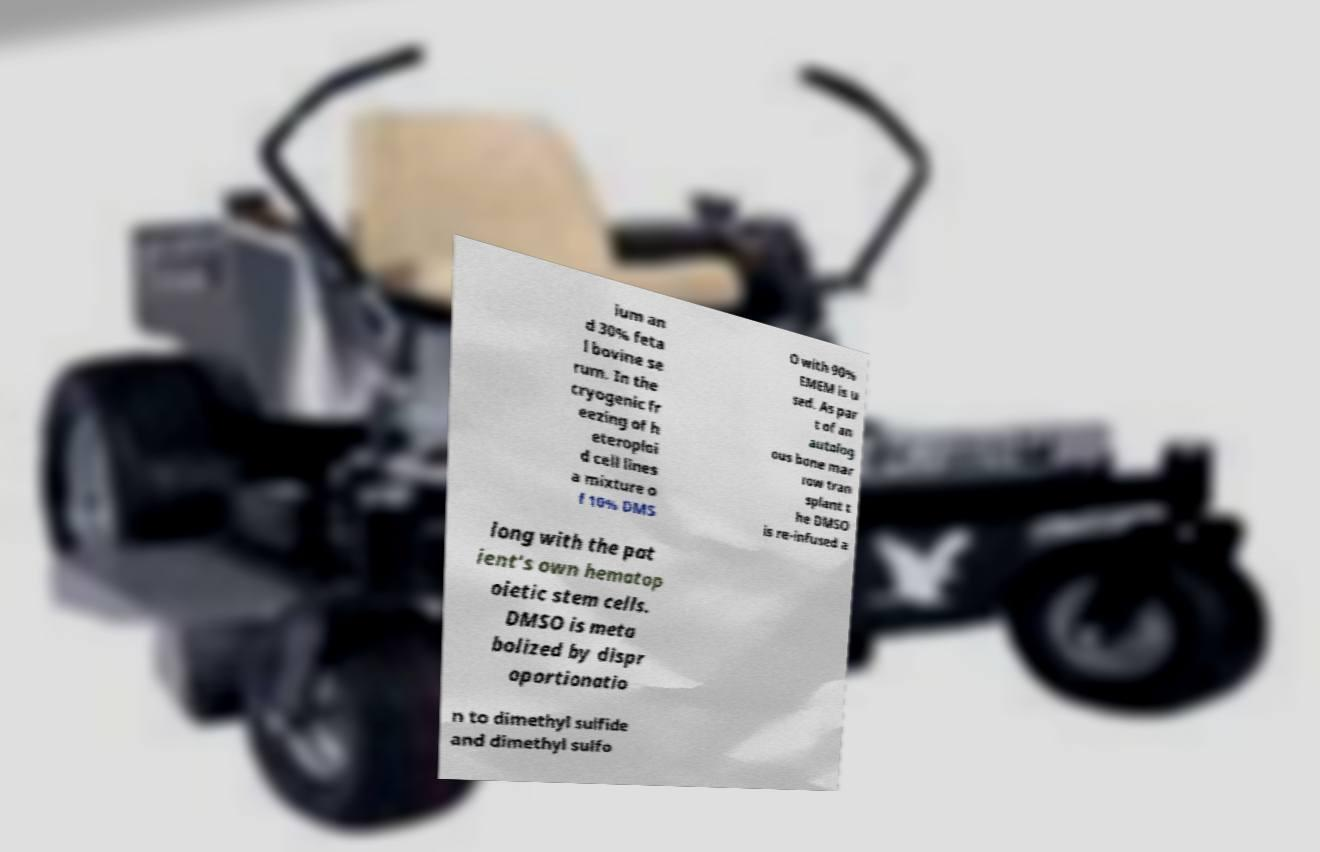Can you read and provide the text displayed in the image?This photo seems to have some interesting text. Can you extract and type it out for me? ium an d 30% feta l bovine se rum. In the cryogenic fr eezing of h eteroploi d cell lines a mixture o f 10% DMS O with 90% EMEM is u sed. As par t of an autolog ous bone mar row tran splant t he DMSO is re-infused a long with the pat ient's own hematop oietic stem cells. DMSO is meta bolized by dispr oportionatio n to dimethyl sulfide and dimethyl sulfo 